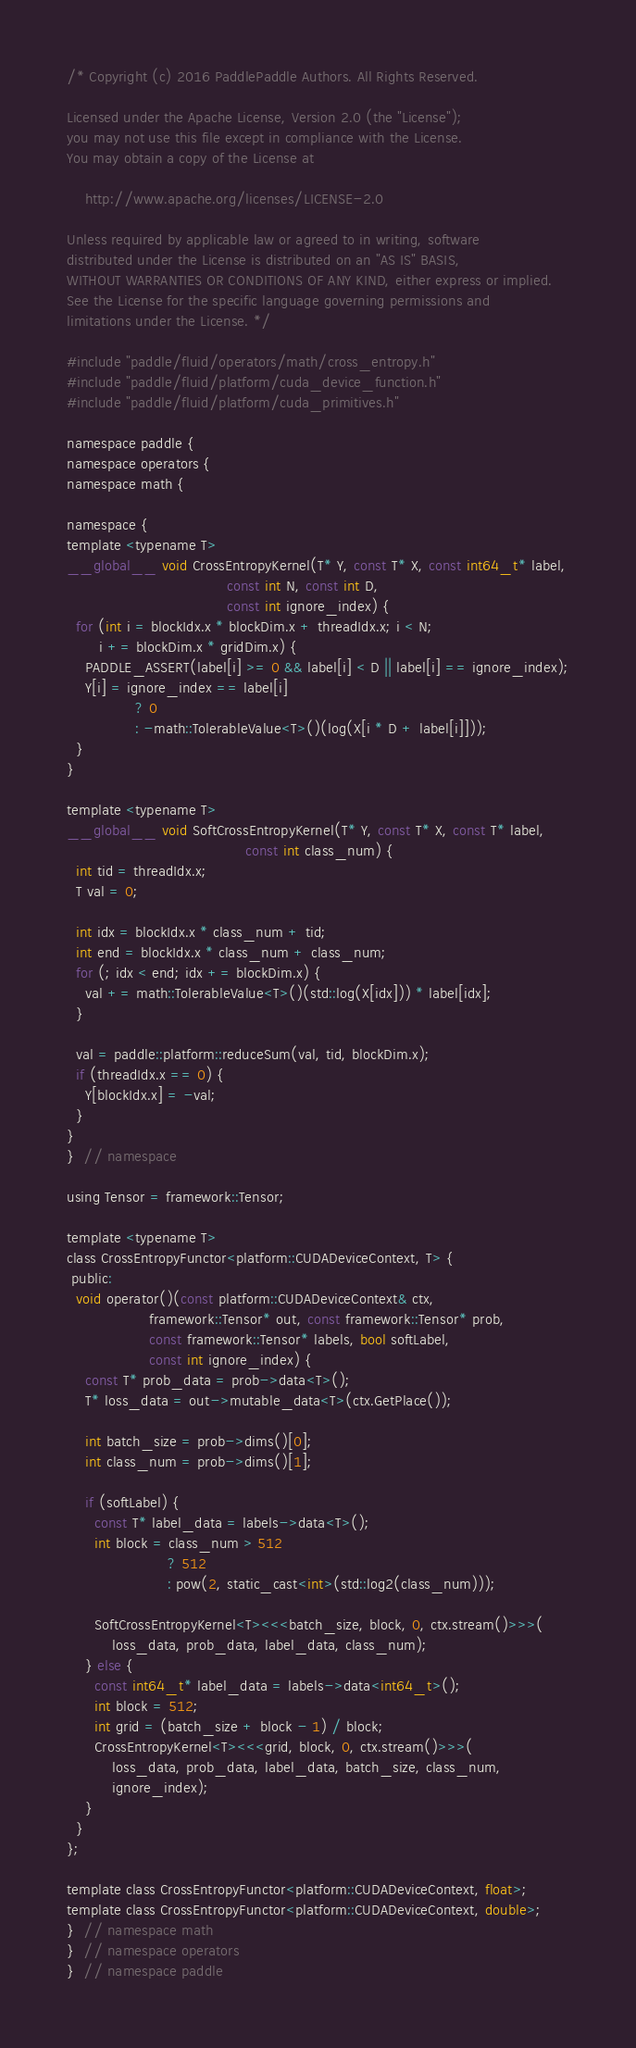Convert code to text. <code><loc_0><loc_0><loc_500><loc_500><_Cuda_>/* Copyright (c) 2016 PaddlePaddle Authors. All Rights Reserved.

Licensed under the Apache License, Version 2.0 (the "License");
you may not use this file except in compliance with the License.
You may obtain a copy of the License at

    http://www.apache.org/licenses/LICENSE-2.0

Unless required by applicable law or agreed to in writing, software
distributed under the License is distributed on an "AS IS" BASIS,
WITHOUT WARRANTIES OR CONDITIONS OF ANY KIND, either express or implied.
See the License for the specific language governing permissions and
limitations under the License. */

#include "paddle/fluid/operators/math/cross_entropy.h"
#include "paddle/fluid/platform/cuda_device_function.h"
#include "paddle/fluid/platform/cuda_primitives.h"

namespace paddle {
namespace operators {
namespace math {

namespace {
template <typename T>
__global__ void CrossEntropyKernel(T* Y, const T* X, const int64_t* label,
                                   const int N, const int D,
                                   const int ignore_index) {
  for (int i = blockIdx.x * blockDim.x + threadIdx.x; i < N;
       i += blockDim.x * gridDim.x) {
    PADDLE_ASSERT(label[i] >= 0 && label[i] < D || label[i] == ignore_index);
    Y[i] = ignore_index == label[i]
               ? 0
               : -math::TolerableValue<T>()(log(X[i * D + label[i]]));
  }
}

template <typename T>
__global__ void SoftCrossEntropyKernel(T* Y, const T* X, const T* label,
                                       const int class_num) {
  int tid = threadIdx.x;
  T val = 0;

  int idx = blockIdx.x * class_num + tid;
  int end = blockIdx.x * class_num + class_num;
  for (; idx < end; idx += blockDim.x) {
    val += math::TolerableValue<T>()(std::log(X[idx])) * label[idx];
  }

  val = paddle::platform::reduceSum(val, tid, blockDim.x);
  if (threadIdx.x == 0) {
    Y[blockIdx.x] = -val;
  }
}
}  // namespace

using Tensor = framework::Tensor;

template <typename T>
class CrossEntropyFunctor<platform::CUDADeviceContext, T> {
 public:
  void operator()(const platform::CUDADeviceContext& ctx,
                  framework::Tensor* out, const framework::Tensor* prob,
                  const framework::Tensor* labels, bool softLabel,
                  const int ignore_index) {
    const T* prob_data = prob->data<T>();
    T* loss_data = out->mutable_data<T>(ctx.GetPlace());

    int batch_size = prob->dims()[0];
    int class_num = prob->dims()[1];

    if (softLabel) {
      const T* label_data = labels->data<T>();
      int block = class_num > 512
                      ? 512
                      : pow(2, static_cast<int>(std::log2(class_num)));

      SoftCrossEntropyKernel<T><<<batch_size, block, 0, ctx.stream()>>>(
          loss_data, prob_data, label_data, class_num);
    } else {
      const int64_t* label_data = labels->data<int64_t>();
      int block = 512;
      int grid = (batch_size + block - 1) / block;
      CrossEntropyKernel<T><<<grid, block, 0, ctx.stream()>>>(
          loss_data, prob_data, label_data, batch_size, class_num,
          ignore_index);
    }
  }
};

template class CrossEntropyFunctor<platform::CUDADeviceContext, float>;
template class CrossEntropyFunctor<platform::CUDADeviceContext, double>;
}  // namespace math
}  // namespace operators
}  // namespace paddle
</code> 